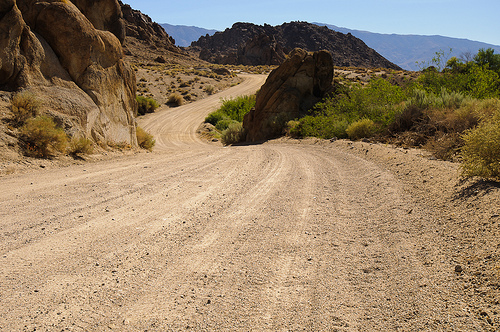<image>
Is the rock next to the street? Yes. The rock is positioned adjacent to the street, located nearby in the same general area. 